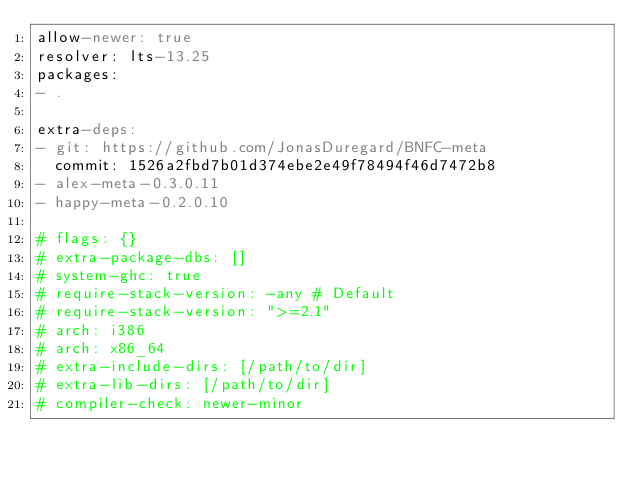Convert code to text. <code><loc_0><loc_0><loc_500><loc_500><_YAML_>allow-newer: true
resolver: lts-13.25
packages:
- .

extra-deps:
- git: https://github.com/JonasDuregard/BNFC-meta
  commit: 1526a2fbd7b01d374ebe2e49f78494f46d7472b8
- alex-meta-0.3.0.11
- happy-meta-0.2.0.10

# flags: {}
# extra-package-dbs: []
# system-ghc: true
# require-stack-version: -any # Default
# require-stack-version: ">=2.1"
# arch: i386
# arch: x86_64
# extra-include-dirs: [/path/to/dir]
# extra-lib-dirs: [/path/to/dir]
# compiler-check: newer-minor
</code> 